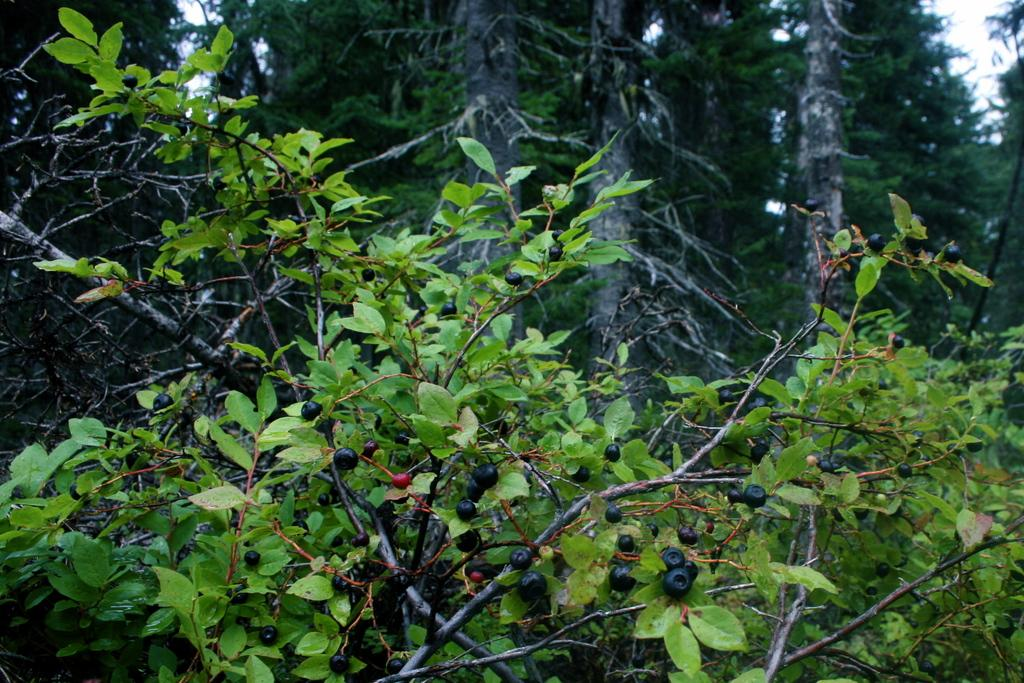What type of food items can be seen in the image? There are fruits in the image. What other living organism is present in the image? There is a plant in the image. What can be seen in the background of the image? Trees and the sky are visible in the background of the image. What type of coat is the plant wearing in the image? There is no coat present in the image, as plants do not wear clothing. 